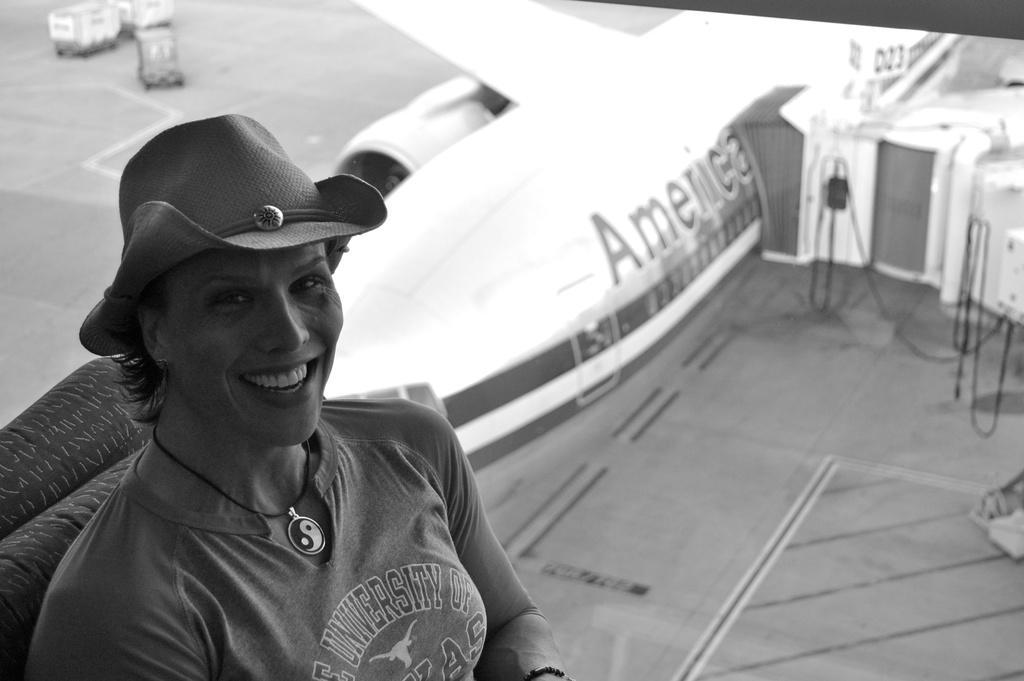Describe this image in one or two sentences. This is a black and white image. In the foreground of the image there is a lady wearing a hat. In the background of the image there is a aeroplane. There are trucks in the image. 